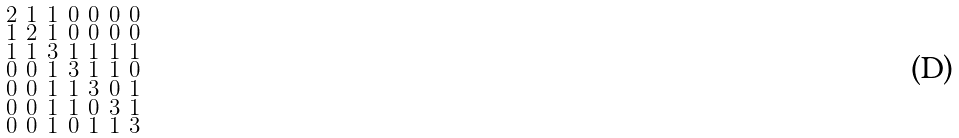<formula> <loc_0><loc_0><loc_500><loc_500>\begin{smallmatrix} 2 & 1 & 1 & 0 & 0 & 0 & 0 \\ 1 & 2 & 1 & 0 & 0 & 0 & 0 \\ 1 & 1 & 3 & 1 & 1 & 1 & 1 \\ 0 & 0 & 1 & 3 & 1 & 1 & 0 \\ 0 & 0 & 1 & 1 & 3 & 0 & 1 \\ 0 & 0 & 1 & 1 & 0 & 3 & 1 \\ 0 & 0 & 1 & 0 & 1 & 1 & 3 \end{smallmatrix}</formula> 